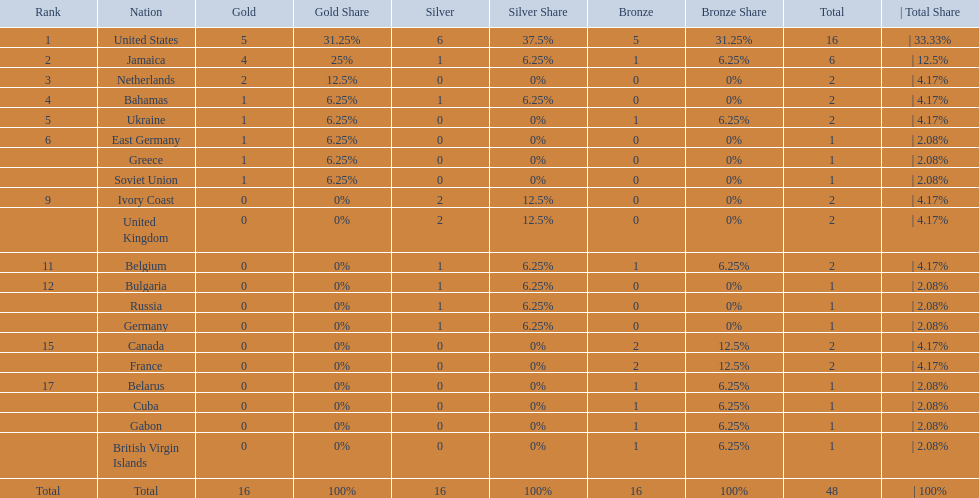What countries competed? United States, Jamaica, Netherlands, Bahamas, Ukraine, East Germany, Greece, Soviet Union, Ivory Coast, United Kingdom, Belgium, Bulgaria, Russia, Germany, Canada, France, Belarus, Cuba, Gabon, British Virgin Islands. Which countries won gold medals? United States, Jamaica, Netherlands, Bahamas, Ukraine, East Germany, Greece, Soviet Union. Which country had the second most medals? Jamaica. 